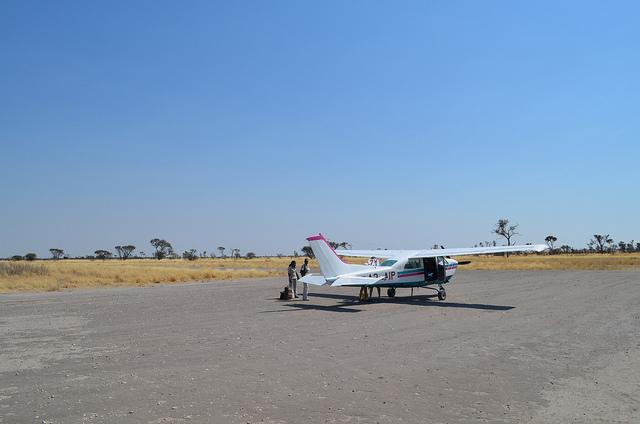What biome is in the background?

Choices:
A) desert
B) tundra
C) rainforest
D) savanna savanna 